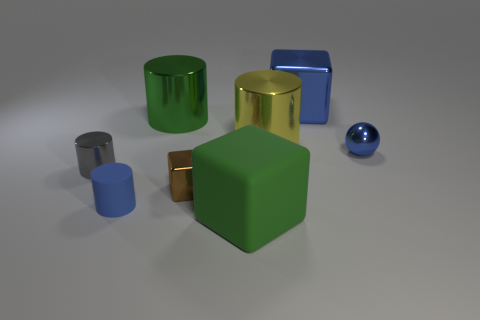What color is the cube that is the same size as the blue metal sphere?
Offer a very short reply. Brown. There is a large yellow thing; does it have the same shape as the green object that is in front of the blue rubber thing?
Offer a very short reply. No. There is a cube behind the tiny cylinder that is behind the small cylinder that is in front of the small gray metal thing; what is its material?
Provide a succinct answer. Metal. How many small objects are either gray cubes or green shiny things?
Offer a very short reply. 0. What number of other things are there of the same size as the gray cylinder?
Provide a succinct answer. 3. There is a metal object to the left of the blue rubber thing; does it have the same shape as the blue matte object?
Your answer should be very brief. Yes. What is the color of the other small thing that is the same shape as the tiny blue rubber object?
Your response must be concise. Gray. Is there any other thing that has the same shape as the big green shiny thing?
Offer a very short reply. Yes. Are there the same number of metallic cubes that are in front of the green cube and tiny brown metallic things?
Offer a terse response. No. How many metallic things are on the left side of the big blue thing and behind the small blue metallic object?
Offer a very short reply. 2. 